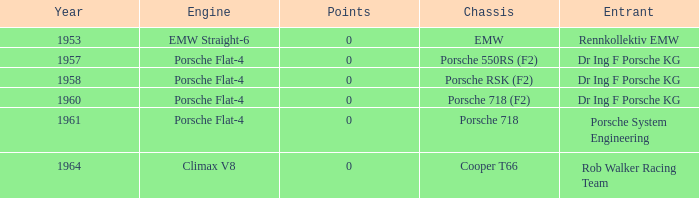What chassis did the porsche flat-4 use before 1958? Porsche 550RS (F2). 